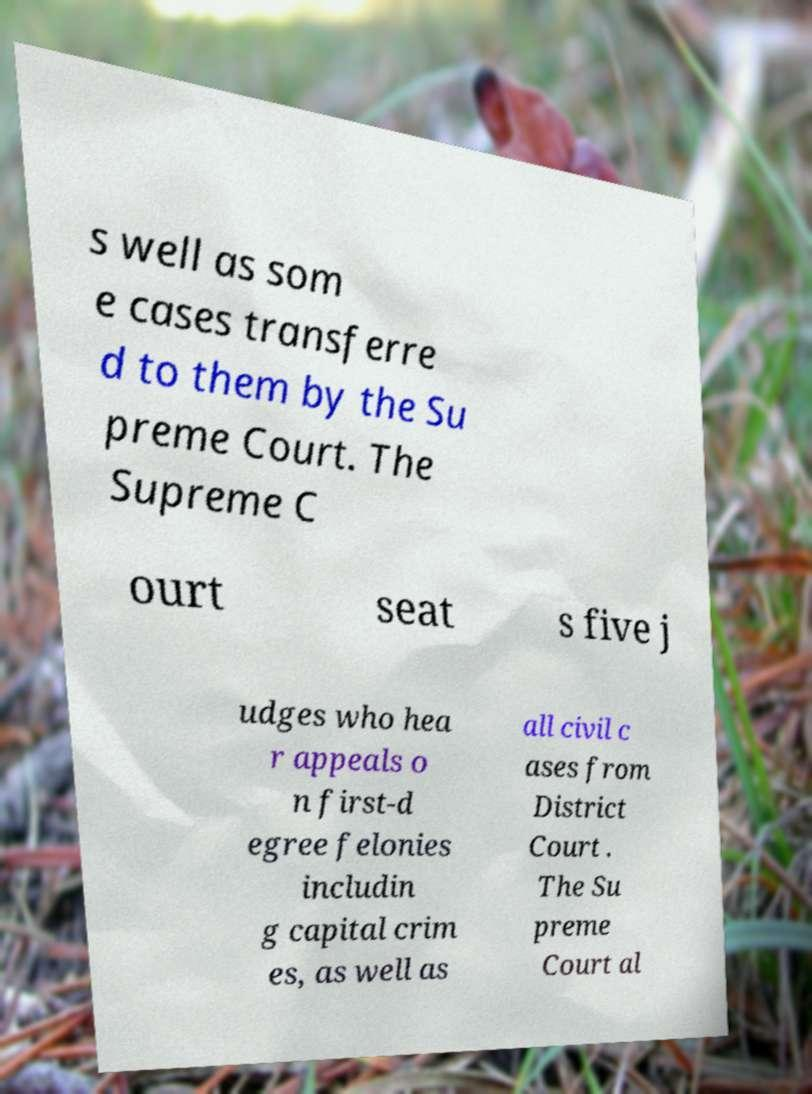What messages or text are displayed in this image? I need them in a readable, typed format. s well as som e cases transferre d to them by the Su preme Court. The Supreme C ourt seat s five j udges who hea r appeals o n first-d egree felonies includin g capital crim es, as well as all civil c ases from District Court . The Su preme Court al 